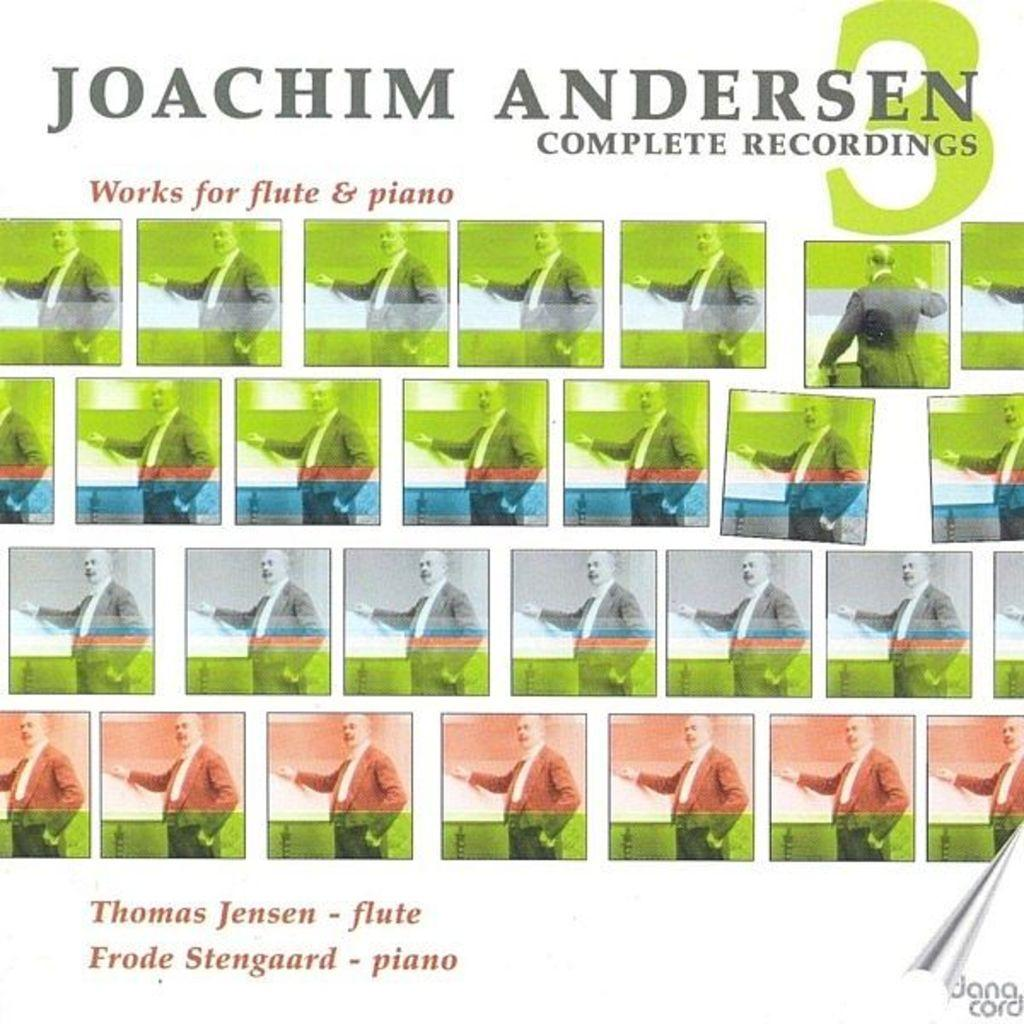What is the main subject of the image? There is a person standing in the image. What type of text can be seen in the image? There is text at the top and bottom of the image. What type of car is visible in the image? There is no car present in the image; it features a person standing and text at the top and bottom. What type of agreement is being made between the person and the text in the image? There is no agreement being made in the image, as it only shows a person standing and text at the top and bottom. 